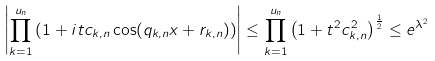Convert formula to latex. <formula><loc_0><loc_0><loc_500><loc_500>\left | \prod _ { k = 1 } ^ { u _ { n } } \left ( 1 + i t c _ { k , n } \cos ( q _ { k , n } x + r _ { k , n } ) \right ) \right | \leq \prod _ { k = 1 } ^ { u _ { n } } \left ( 1 + t ^ { 2 } c _ { k , n } ^ { 2 } \right ) ^ { \frac { 1 } { 2 } } \leq e ^ { \lambda ^ { 2 } }</formula> 